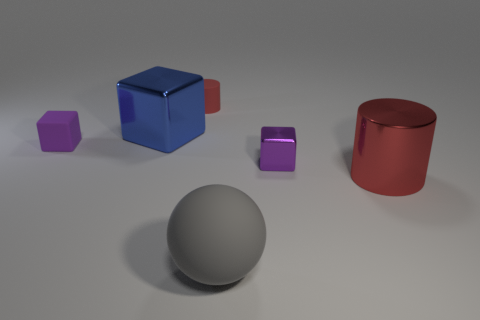Add 2 large red shiny objects. How many objects exist? 8 Subtract all balls. How many objects are left? 5 Subtract 0 cyan cubes. How many objects are left? 6 Subtract all metallic cylinders. Subtract all large metallic things. How many objects are left? 3 Add 3 purple matte blocks. How many purple matte blocks are left? 4 Add 5 large gray things. How many large gray things exist? 6 